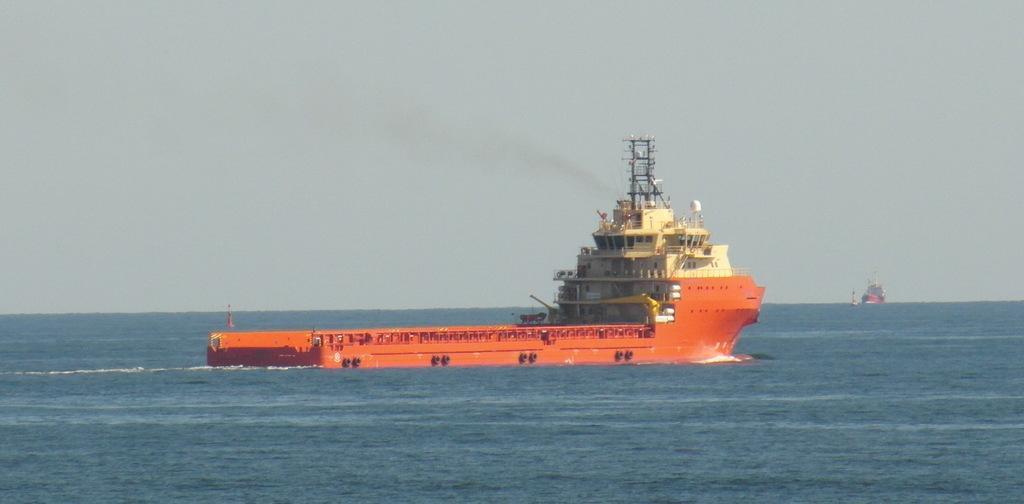Can you describe this image briefly? In this image we can see a ship on the surface of the water. In the background we can also see another ship. 